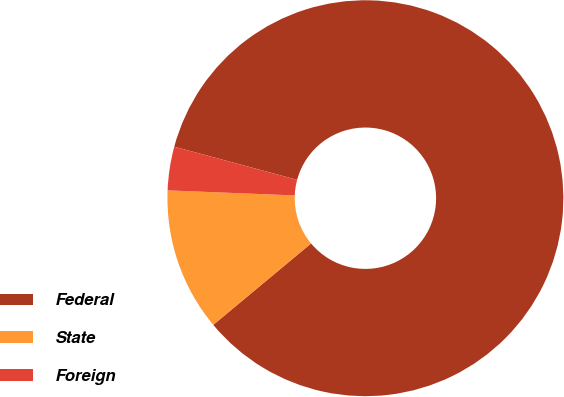Convert chart to OTSL. <chart><loc_0><loc_0><loc_500><loc_500><pie_chart><fcel>Federal<fcel>State<fcel>Foreign<nl><fcel>84.76%<fcel>11.68%<fcel>3.56%<nl></chart> 